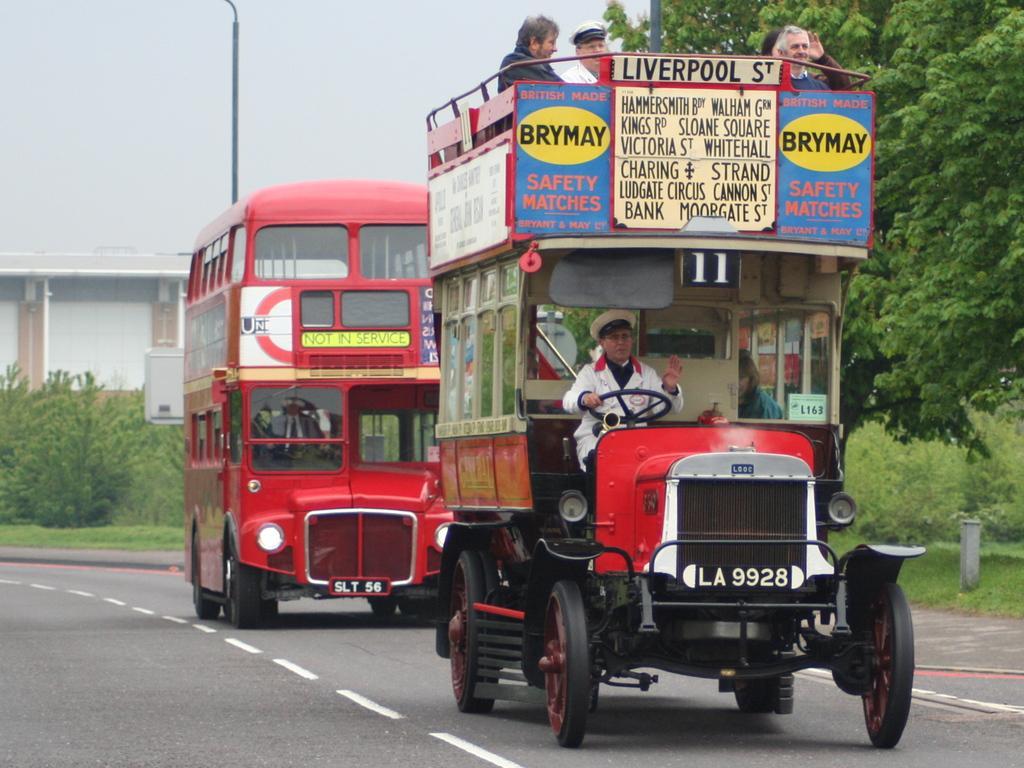Please provide a concise description of this image. In this image we can see motor vehicles and persons travelling in it, road, bushes, trees, poles, buildings and sky. 